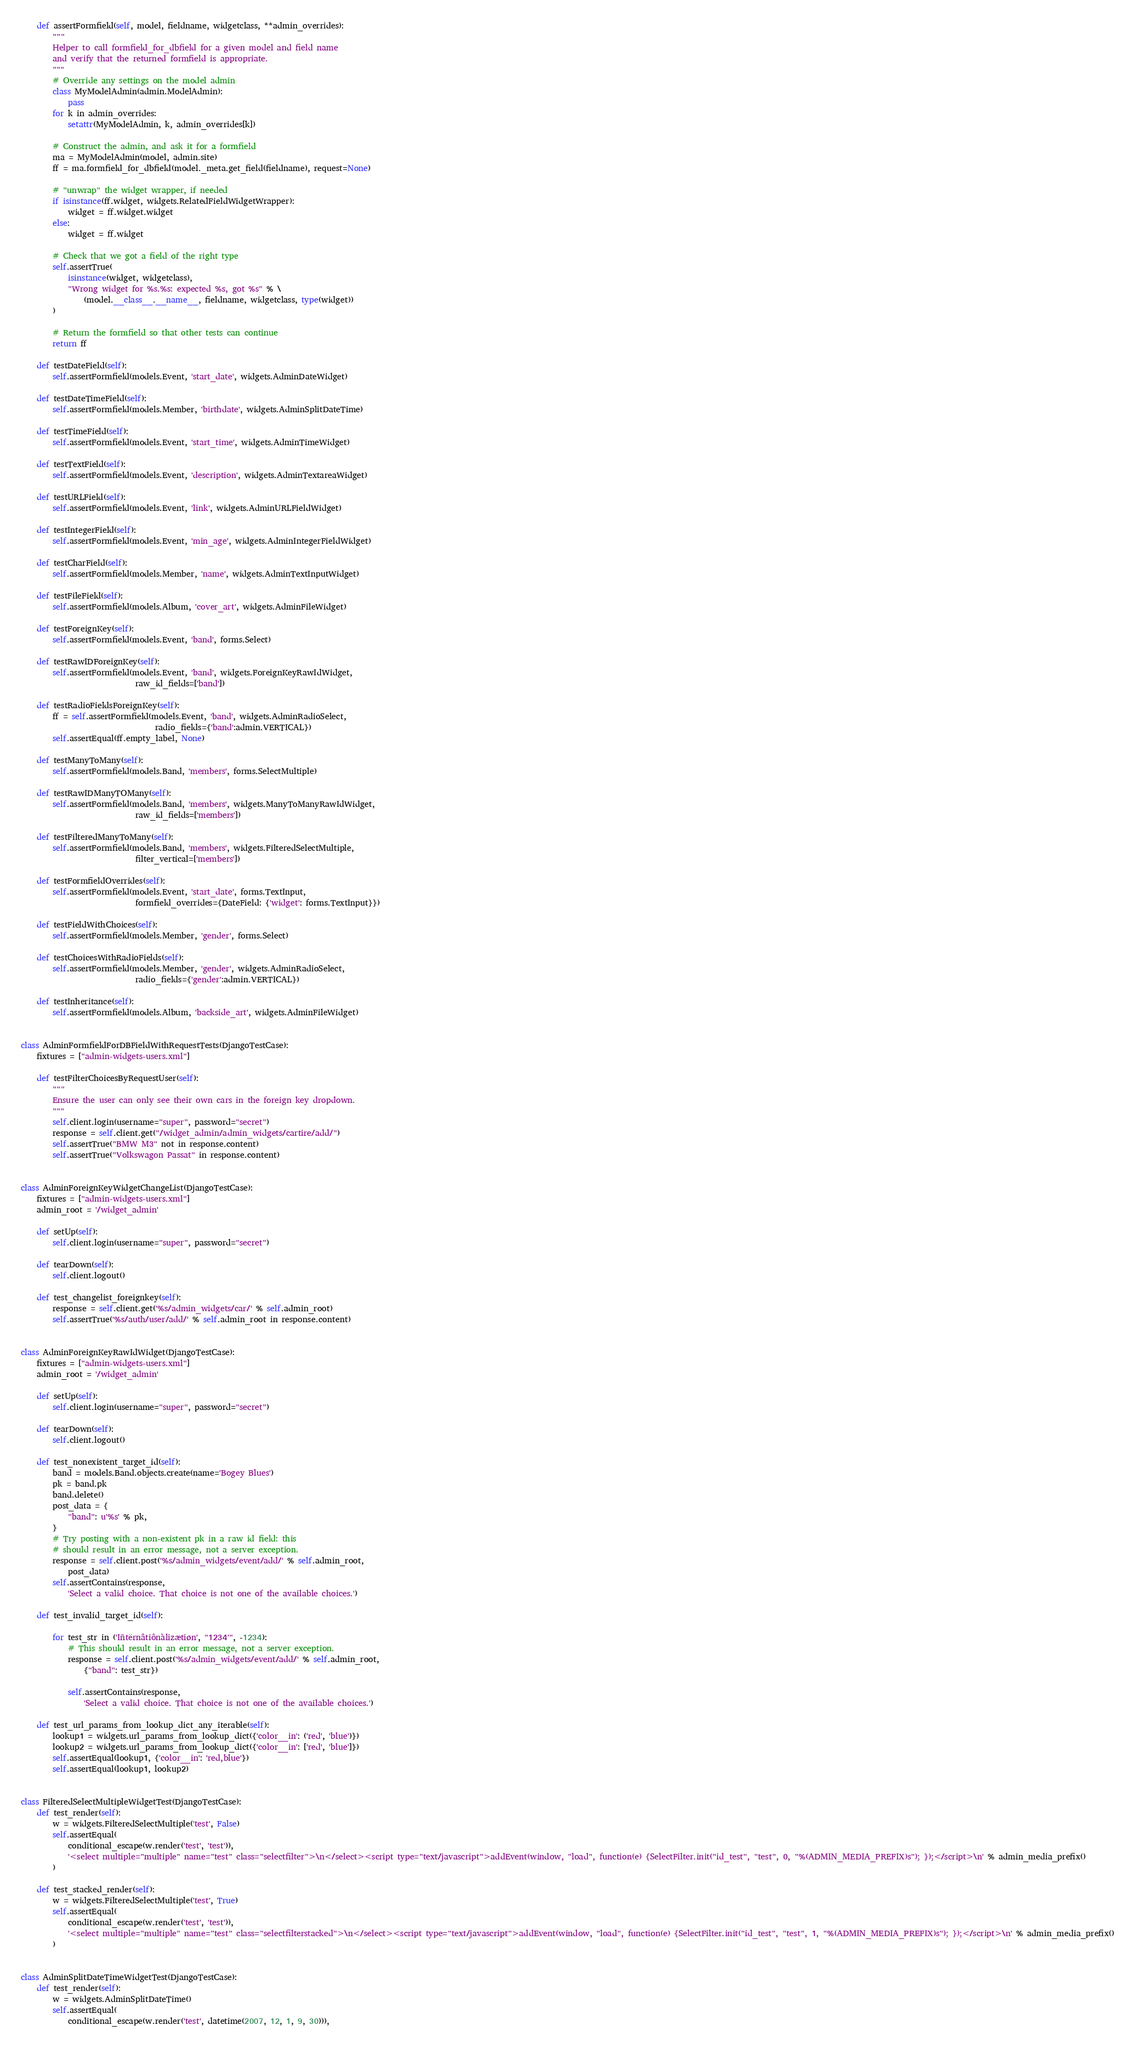Convert code to text. <code><loc_0><loc_0><loc_500><loc_500><_Python_>    def assertFormfield(self, model, fieldname, widgetclass, **admin_overrides):
        """
        Helper to call formfield_for_dbfield for a given model and field name
        and verify that the returned formfield is appropriate.
        """
        # Override any settings on the model admin
        class MyModelAdmin(admin.ModelAdmin):
            pass
        for k in admin_overrides:
            setattr(MyModelAdmin, k, admin_overrides[k])

        # Construct the admin, and ask it for a formfield
        ma = MyModelAdmin(model, admin.site)
        ff = ma.formfield_for_dbfield(model._meta.get_field(fieldname), request=None)

        # "unwrap" the widget wrapper, if needed
        if isinstance(ff.widget, widgets.RelatedFieldWidgetWrapper):
            widget = ff.widget.widget
        else:
            widget = ff.widget

        # Check that we got a field of the right type
        self.assertTrue(
            isinstance(widget, widgetclass),
            "Wrong widget for %s.%s: expected %s, got %s" % \
                (model.__class__.__name__, fieldname, widgetclass, type(widget))
        )

        # Return the formfield so that other tests can continue
        return ff

    def testDateField(self):
        self.assertFormfield(models.Event, 'start_date', widgets.AdminDateWidget)

    def testDateTimeField(self):
        self.assertFormfield(models.Member, 'birthdate', widgets.AdminSplitDateTime)

    def testTimeField(self):
        self.assertFormfield(models.Event, 'start_time', widgets.AdminTimeWidget)

    def testTextField(self):
        self.assertFormfield(models.Event, 'description', widgets.AdminTextareaWidget)

    def testURLField(self):
        self.assertFormfield(models.Event, 'link', widgets.AdminURLFieldWidget)

    def testIntegerField(self):
        self.assertFormfield(models.Event, 'min_age', widgets.AdminIntegerFieldWidget)

    def testCharField(self):
        self.assertFormfield(models.Member, 'name', widgets.AdminTextInputWidget)

    def testFileField(self):
        self.assertFormfield(models.Album, 'cover_art', widgets.AdminFileWidget)

    def testForeignKey(self):
        self.assertFormfield(models.Event, 'band', forms.Select)

    def testRawIDForeignKey(self):
        self.assertFormfield(models.Event, 'band', widgets.ForeignKeyRawIdWidget,
                             raw_id_fields=['band'])

    def testRadioFieldsForeignKey(self):
        ff = self.assertFormfield(models.Event, 'band', widgets.AdminRadioSelect,
                                  radio_fields={'band':admin.VERTICAL})
        self.assertEqual(ff.empty_label, None)

    def testManyToMany(self):
        self.assertFormfield(models.Band, 'members', forms.SelectMultiple)

    def testRawIDManyTOMany(self):
        self.assertFormfield(models.Band, 'members', widgets.ManyToManyRawIdWidget,
                             raw_id_fields=['members'])

    def testFilteredManyToMany(self):
        self.assertFormfield(models.Band, 'members', widgets.FilteredSelectMultiple,
                             filter_vertical=['members'])

    def testFormfieldOverrides(self):
        self.assertFormfield(models.Event, 'start_date', forms.TextInput,
                             formfield_overrides={DateField: {'widget': forms.TextInput}})

    def testFieldWithChoices(self):
        self.assertFormfield(models.Member, 'gender', forms.Select)

    def testChoicesWithRadioFields(self):
        self.assertFormfield(models.Member, 'gender', widgets.AdminRadioSelect,
                             radio_fields={'gender':admin.VERTICAL})

    def testInheritance(self):
        self.assertFormfield(models.Album, 'backside_art', widgets.AdminFileWidget)


class AdminFormfieldForDBFieldWithRequestTests(DjangoTestCase):
    fixtures = ["admin-widgets-users.xml"]

    def testFilterChoicesByRequestUser(self):
        """
        Ensure the user can only see their own cars in the foreign key dropdown.
        """
        self.client.login(username="super", password="secret")
        response = self.client.get("/widget_admin/admin_widgets/cartire/add/")
        self.assertTrue("BMW M3" not in response.content)
        self.assertTrue("Volkswagon Passat" in response.content)


class AdminForeignKeyWidgetChangeList(DjangoTestCase):
    fixtures = ["admin-widgets-users.xml"]
    admin_root = '/widget_admin'

    def setUp(self):
        self.client.login(username="super", password="secret")

    def tearDown(self):
        self.client.logout()

    def test_changelist_foreignkey(self):
        response = self.client.get('%s/admin_widgets/car/' % self.admin_root)
        self.assertTrue('%s/auth/user/add/' % self.admin_root in response.content)


class AdminForeignKeyRawIdWidget(DjangoTestCase):
    fixtures = ["admin-widgets-users.xml"]
    admin_root = '/widget_admin'

    def setUp(self):
        self.client.login(username="super", password="secret")

    def tearDown(self):
        self.client.logout()

    def test_nonexistent_target_id(self):
        band = models.Band.objects.create(name='Bogey Blues')
        pk = band.pk
        band.delete()
        post_data = {
            "band": u'%s' % pk,
        }
        # Try posting with a non-existent pk in a raw id field: this
        # should result in an error message, not a server exception.
        response = self.client.post('%s/admin_widgets/event/add/' % self.admin_root,
            post_data)
        self.assertContains(response,
            'Select a valid choice. That choice is not one of the available choices.')

    def test_invalid_target_id(self):

        for test_str in ('Iñtërnâtiônàlizætiøn', "1234'", -1234):
            # This should result in an error message, not a server exception.
            response = self.client.post('%s/admin_widgets/event/add/' % self.admin_root,
                {"band": test_str})

            self.assertContains(response,
                'Select a valid choice. That choice is not one of the available choices.')

    def test_url_params_from_lookup_dict_any_iterable(self):
        lookup1 = widgets.url_params_from_lookup_dict({'color__in': ('red', 'blue')})
        lookup2 = widgets.url_params_from_lookup_dict({'color__in': ['red', 'blue']})
        self.assertEqual(lookup1, {'color__in': 'red,blue'})
        self.assertEqual(lookup1, lookup2)


class FilteredSelectMultipleWidgetTest(DjangoTestCase):
    def test_render(self):
        w = widgets.FilteredSelectMultiple('test', False)
        self.assertEqual(
            conditional_escape(w.render('test', 'test')),
            '<select multiple="multiple" name="test" class="selectfilter">\n</select><script type="text/javascript">addEvent(window, "load", function(e) {SelectFilter.init("id_test", "test", 0, "%(ADMIN_MEDIA_PREFIX)s"); });</script>\n' % admin_media_prefix()
        )

    def test_stacked_render(self):
        w = widgets.FilteredSelectMultiple('test', True)
        self.assertEqual(
            conditional_escape(w.render('test', 'test')),
            '<select multiple="multiple" name="test" class="selectfilterstacked">\n</select><script type="text/javascript">addEvent(window, "load", function(e) {SelectFilter.init("id_test", "test", 1, "%(ADMIN_MEDIA_PREFIX)s"); });</script>\n' % admin_media_prefix()
        )


class AdminSplitDateTimeWidgetTest(DjangoTestCase):
    def test_render(self):
        w = widgets.AdminSplitDateTime()
        self.assertEqual(
            conditional_escape(w.render('test', datetime(2007, 12, 1, 9, 30))),</code> 